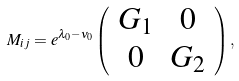<formula> <loc_0><loc_0><loc_500><loc_500>M _ { i j } = e ^ { \lambda _ { 0 } - \nu _ { 0 } } \left ( \begin{array} { c c } G _ { 1 } & 0 \\ 0 & G _ { 2 } \end{array} \right ) ,</formula> 